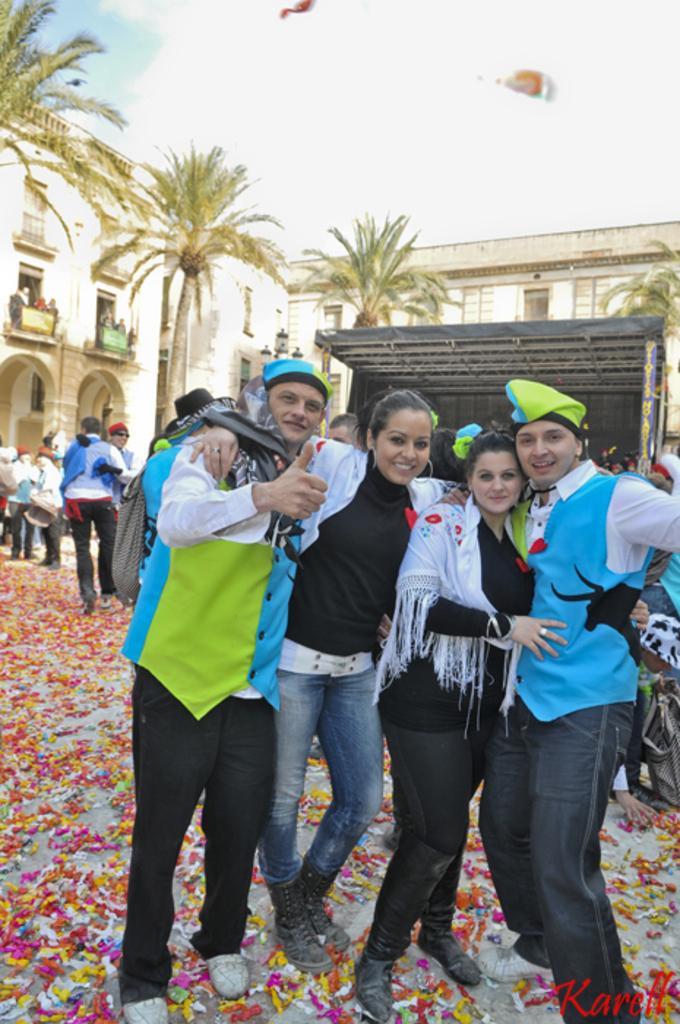How would you summarize this image in a sentence or two? In this image there are many people standing on the ground. In the foreground there are four people standing. They are holding each other and they are smiling. There are papers on the ground. Behind them there are buildings. In front of the buildings there are trees. To the right there is a shed behind them. At the top there is the sky. In the bottom right there is text on the image. 